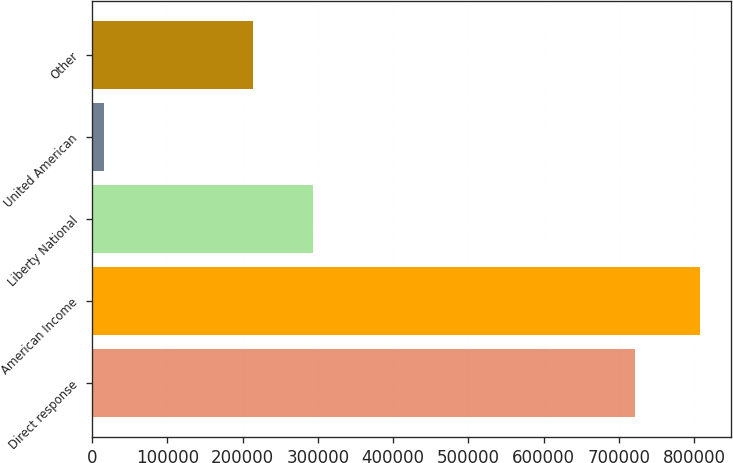Convert chart to OTSL. <chart><loc_0><loc_0><loc_500><loc_500><bar_chart><fcel>Direct response<fcel>American Income<fcel>Liberty National<fcel>United American<fcel>Other<nl><fcel>721261<fcel>807935<fcel>293527<fcel>15831<fcel>214317<nl></chart> 